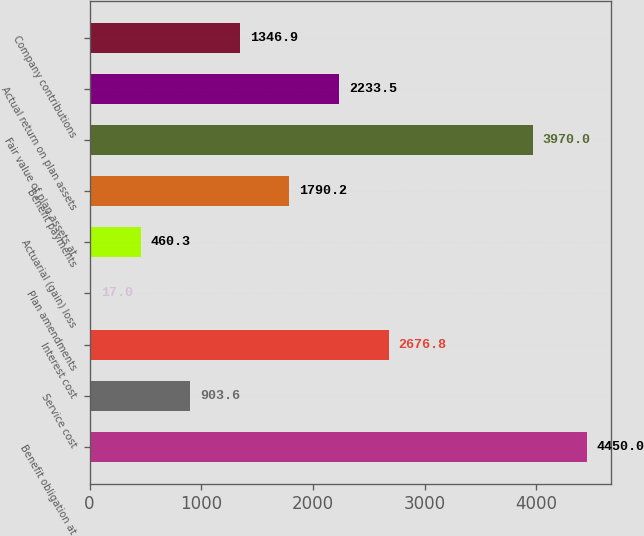Convert chart to OTSL. <chart><loc_0><loc_0><loc_500><loc_500><bar_chart><fcel>Benefit obligation at<fcel>Service cost<fcel>Interest cost<fcel>Plan amendments<fcel>Actuarial (gain) loss<fcel>Benefit payments<fcel>Fair value of plan assets at<fcel>Actual return on plan assets<fcel>Company contributions<nl><fcel>4450<fcel>903.6<fcel>2676.8<fcel>17<fcel>460.3<fcel>1790.2<fcel>3970<fcel>2233.5<fcel>1346.9<nl></chart> 